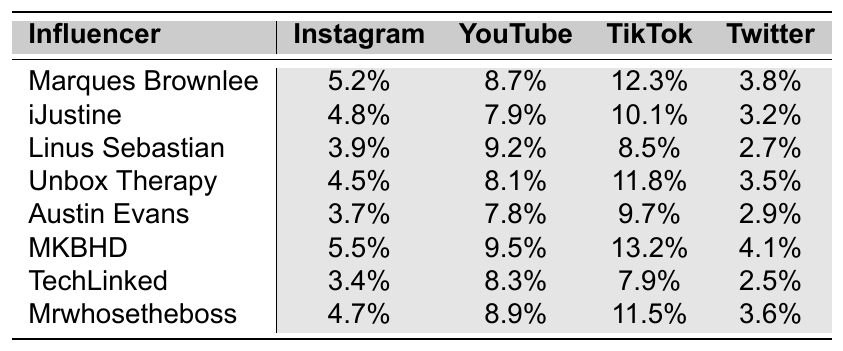What is the highest engagement rate on Instagram among the influencers? The highest engagement rate on Instagram is found by comparing all the values in the Instagram column. The highest value is 5.5%, associated with MKBHD.
Answer: 5.5% Which influencer has the lowest TikTok engagement rate? To find the lowest TikTok engagement rate, I check the TikTok column for the smallest value. The lowest engagement rate is 7.9%, which is for TechLinked.
Answer: 7.9% What is the average engagement rate for YouTube across all influencers? I sum up the YouTube engagement rates: 8.7 + 7.9 + 9.2 + 8.1 + 7.8 + 9.5 + 8.3 + 8.9 = 69.4. Then I divide by the number of influencers (8): 69.4 / 8 = 8.675.
Answer: 8.675% Which influencer has the highest engagement rate on Twitter? The highest engagement rate on Twitter is found by looking at the Twitter column. The highest value is 4.1%, associated with MKBHD.
Answer: 4.1% Is Marques Brownlee's TikTok engagement rate higher than Mrwhosetheboss's? Marques Brownlee's TikTok engagement rate is 12.3%, while Mrwhosetheboss's is 11.5%. Since 12.3% is greater than 11.5%, the statement is true.
Answer: Yes What is the difference between MKBHD's Instagram and Twitter engagement rates? To find the difference, I subtract MKBHD's Twitter engagement rate (4.1%) from their Instagram engagement rate (5.5%). The calculation is 5.5 - 4.1 = 1.4.
Answer: 1.4% Which platform shows the highest engagement rate for Unbox Therapy? By checking Unbox Therapy's engagement rates across all platforms, I see that TikTok has the highest engagement rate at 11.8%.
Answer: 11.8% If we consider Linus Sebastian and Austin Evans together, who has a higher engagement rate on Instagram? Linus Sebastian's Instagram rate is 3.9%, and Austin Evans's is 3.7%. Comparing the two, Linus Sebastian has the higher rate since 3.9% is greater than 3.7%.
Answer: Linus Sebastian What is the total engagement rate for Mrwhosetheboss across all platforms? To calculate the total, I add Mrwhosetheboss's rates: 4.7 + 8.9 + 11.5 + 3.6 = 28.7.
Answer: 28.7 Who has a higher engagement rate on Instagram, iJustine or Unbox Therapy? iJustine's Instagram engagement rate is 4.8%, while Unbox Therapy's is 4.5%. Since 4.8% is greater than 4.5%, iJustine has the higher engagement rate.
Answer: iJustine 